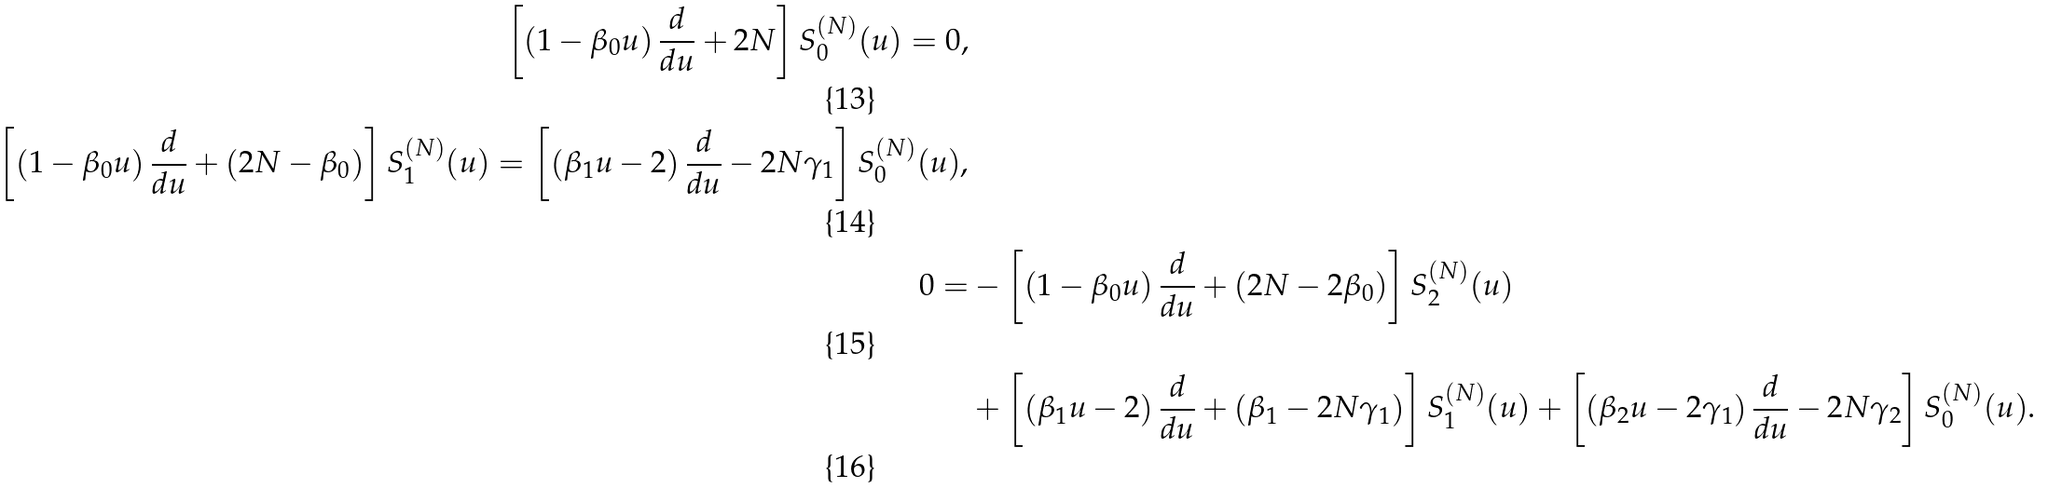Convert formula to latex. <formula><loc_0><loc_0><loc_500><loc_500>\left [ \left ( 1 - \beta _ { 0 } u \right ) \frac { d } { d u } + 2 N \right ] S _ { 0 } ^ { ( N ) } ( u ) = 0 , \\ \left [ \left ( 1 - \beta _ { 0 } u \right ) \frac { d } { d u } + \left ( 2 N - \beta _ { 0 } \right ) \right ] S _ { 1 } ^ { ( N ) } ( u ) = \left [ \left ( \beta _ { 1 } u - 2 \right ) \frac { d } { d u } - 2 N \gamma _ { 1 } \right ] S _ { 0 } ^ { ( N ) } ( u ) , \\ 0 = & - \left [ \left ( 1 - \beta _ { 0 } u \right ) \frac { d } { d u } + \left ( 2 N - 2 \beta _ { 0 } \right ) \right ] S _ { 2 } ^ { ( N ) } ( u ) \\ & + \left [ \left ( \beta _ { 1 } u - 2 \right ) \frac { d } { d u } + \left ( \beta _ { 1 } - 2 N \gamma _ { 1 } \right ) \right ] S _ { 1 } ^ { ( N ) } ( u ) + \left [ \left ( \beta _ { 2 } u - 2 \gamma _ { 1 } \right ) \frac { d } { d u } - 2 N \gamma _ { 2 } \right ] S _ { 0 } ^ { ( N ) } ( u ) .</formula> 